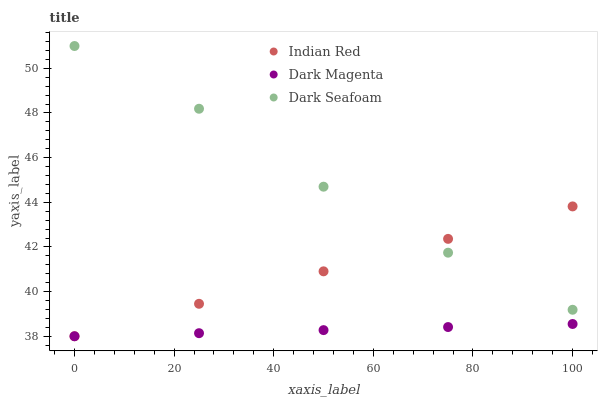Does Dark Magenta have the minimum area under the curve?
Answer yes or no. Yes. Does Dark Seafoam have the maximum area under the curve?
Answer yes or no. Yes. Does Indian Red have the minimum area under the curve?
Answer yes or no. No. Does Indian Red have the maximum area under the curve?
Answer yes or no. No. Is Dark Magenta the smoothest?
Answer yes or no. Yes. Is Dark Seafoam the roughest?
Answer yes or no. Yes. Is Indian Red the smoothest?
Answer yes or no. No. Is Indian Red the roughest?
Answer yes or no. No. Does Dark Magenta have the lowest value?
Answer yes or no. Yes. Does Dark Seafoam have the highest value?
Answer yes or no. Yes. Does Indian Red have the highest value?
Answer yes or no. No. Is Dark Magenta less than Dark Seafoam?
Answer yes or no. Yes. Is Dark Seafoam greater than Dark Magenta?
Answer yes or no. Yes. Does Dark Seafoam intersect Indian Red?
Answer yes or no. Yes. Is Dark Seafoam less than Indian Red?
Answer yes or no. No. Is Dark Seafoam greater than Indian Red?
Answer yes or no. No. Does Dark Magenta intersect Dark Seafoam?
Answer yes or no. No. 